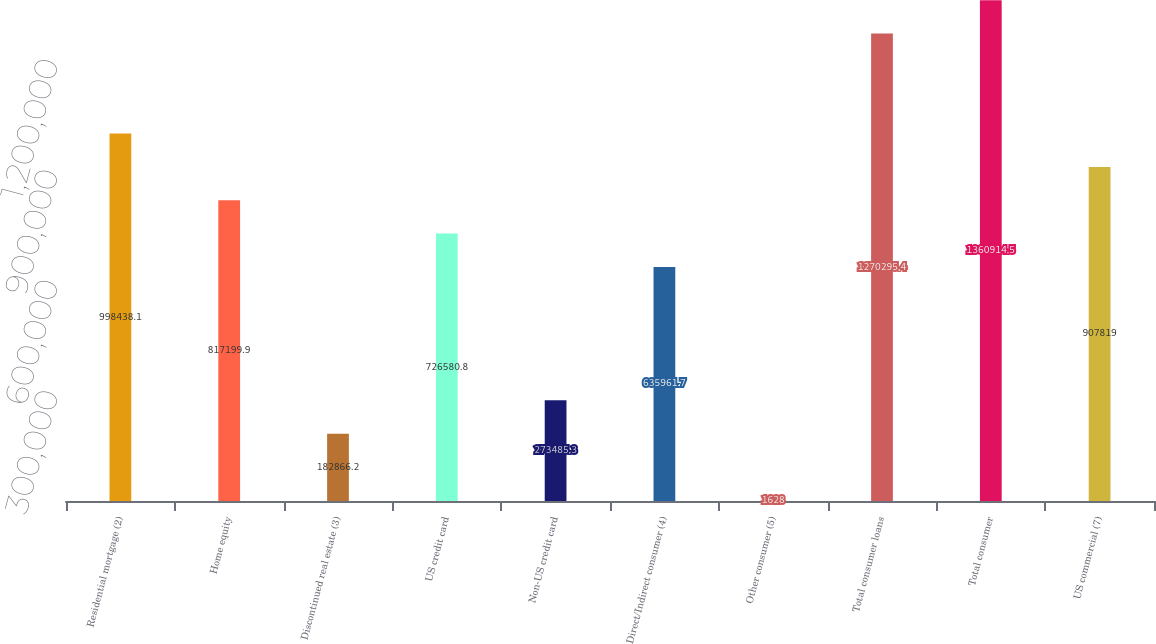<chart> <loc_0><loc_0><loc_500><loc_500><bar_chart><fcel>Residential mortgage (2)<fcel>Home equity<fcel>Discontinued real estate (3)<fcel>US credit card<fcel>Non-US credit card<fcel>Direct/Indirect consumer (4)<fcel>Other consumer (5)<fcel>Total consumer loans<fcel>Total consumer<fcel>US commercial (7)<nl><fcel>998438<fcel>817200<fcel>182866<fcel>726581<fcel>273485<fcel>635962<fcel>1628<fcel>1.2703e+06<fcel>1.36091e+06<fcel>907819<nl></chart> 